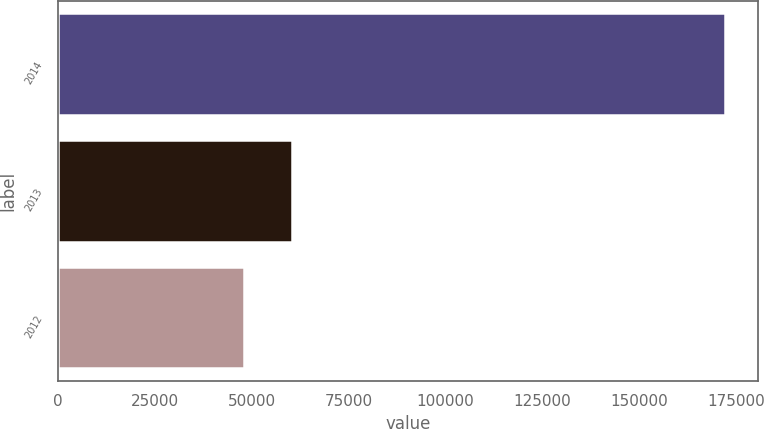<chart> <loc_0><loc_0><loc_500><loc_500><bar_chart><fcel>2014<fcel>2013<fcel>2012<nl><fcel>172010<fcel>60347.9<fcel>47941<nl></chart> 